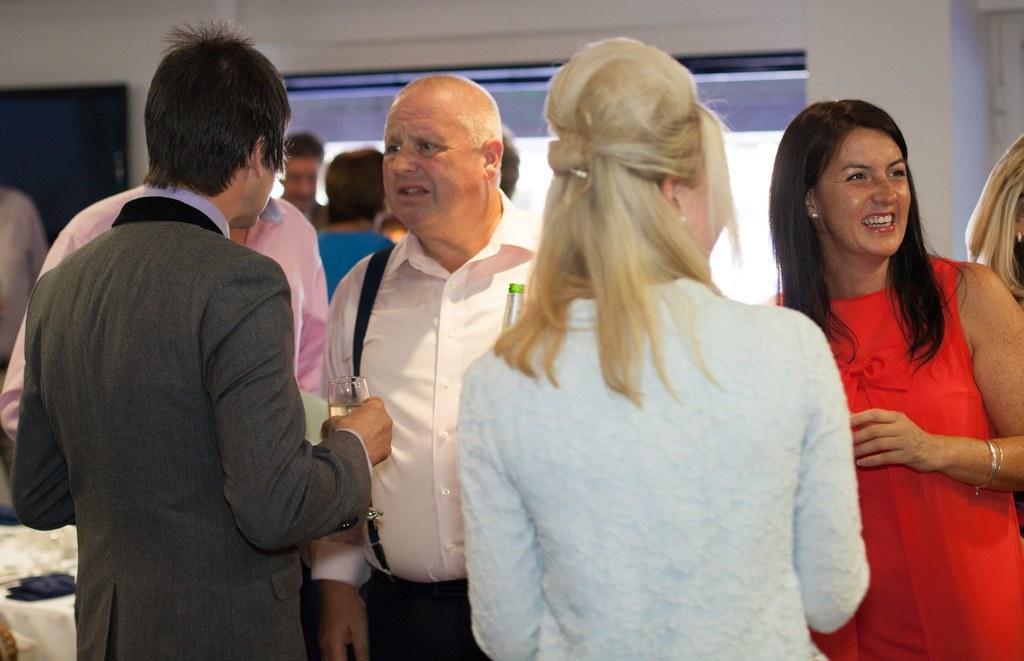Could you give a brief overview of what you see in this image? In this picture we can see a group of people standing and a woman smiling and a man holding a glass with his hand and some objects and in the background we can see the wall and some objects. 